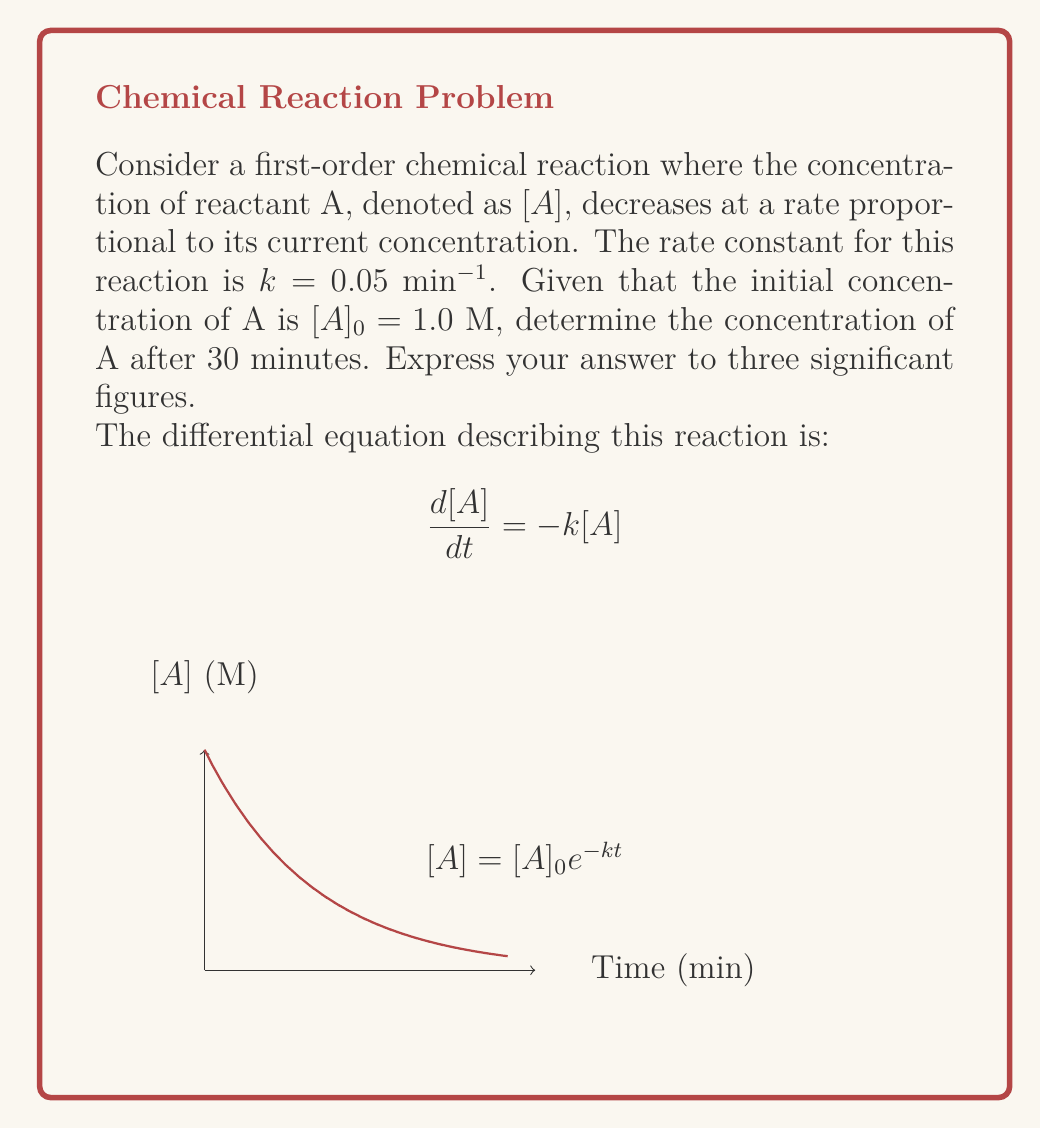Show me your answer to this math problem. Let's approach this step-by-step, as a rigorous chemist would:

1) We begin with the first-order differential equation:
   $$\frac{d[A]}{dt} = -k[A]$$

2) This is a separable differential equation. We can rearrange it:
   $$\frac{d[A]}{[A]} = -k dt$$

3) Integrating both sides from $t=0$ to $t=t$:
   $$\int_{[A]_0}^{[A]} \frac{d[A]}{[A]} = -k \int_0^t dt$$

4) Solving the integrals:
   $$\ln([A]) - \ln([A]_0) = -kt$$

5) Simplifying:
   $$\ln\left(\frac{[A]}{[A]_0}\right) = -kt$$

6) Exponentiating both sides:
   $$\frac{[A]}{[A]_0} = e^{-kt}$$

7) Solving for $[A]$:
   $$[A] = [A]_0e^{-kt}$$

8) Now, we can substitute the given values:
   $[A]_0 = 1.0$ M
   $k = 0.05$ min$^{-1}$
   $t = 30$ min

   $$[A] = 1.0 \cdot e^{-0.05 \cdot 30}$$

9) Calculating:
   $$[A] = 1.0 \cdot e^{-1.5} = 0.22313016...$$

10) Rounding to three significant figures:
    $$[A] = 0.223 \text{ M}$$
Answer: 0.223 M 